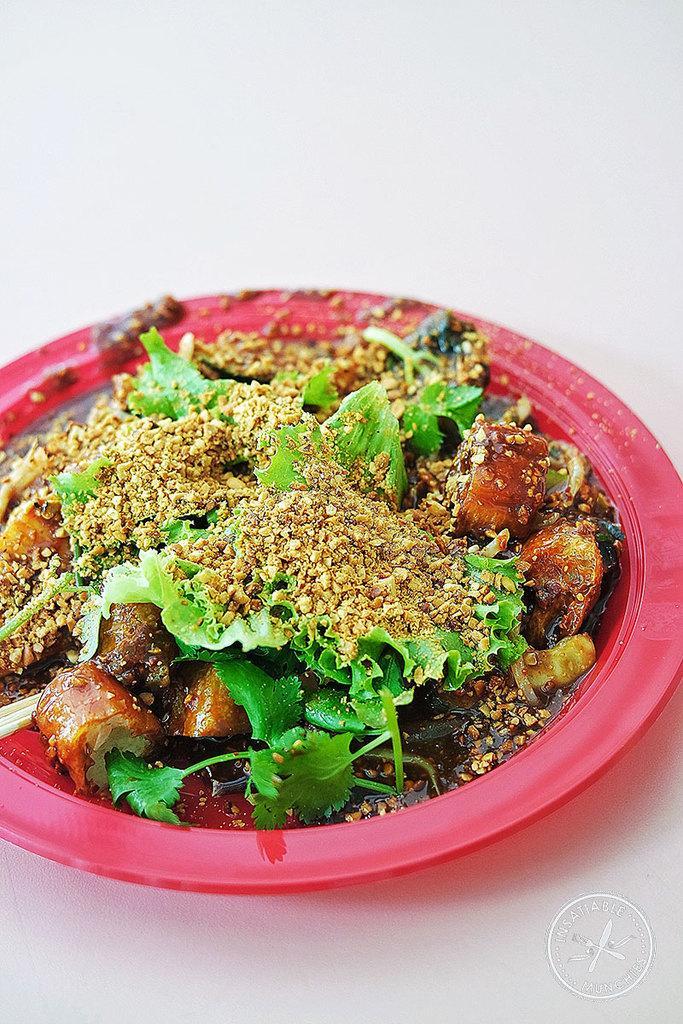Can you describe this image briefly? In the picture we can see a pink colored plate in it we can see some curry with leaf garnish and some powder on it. 